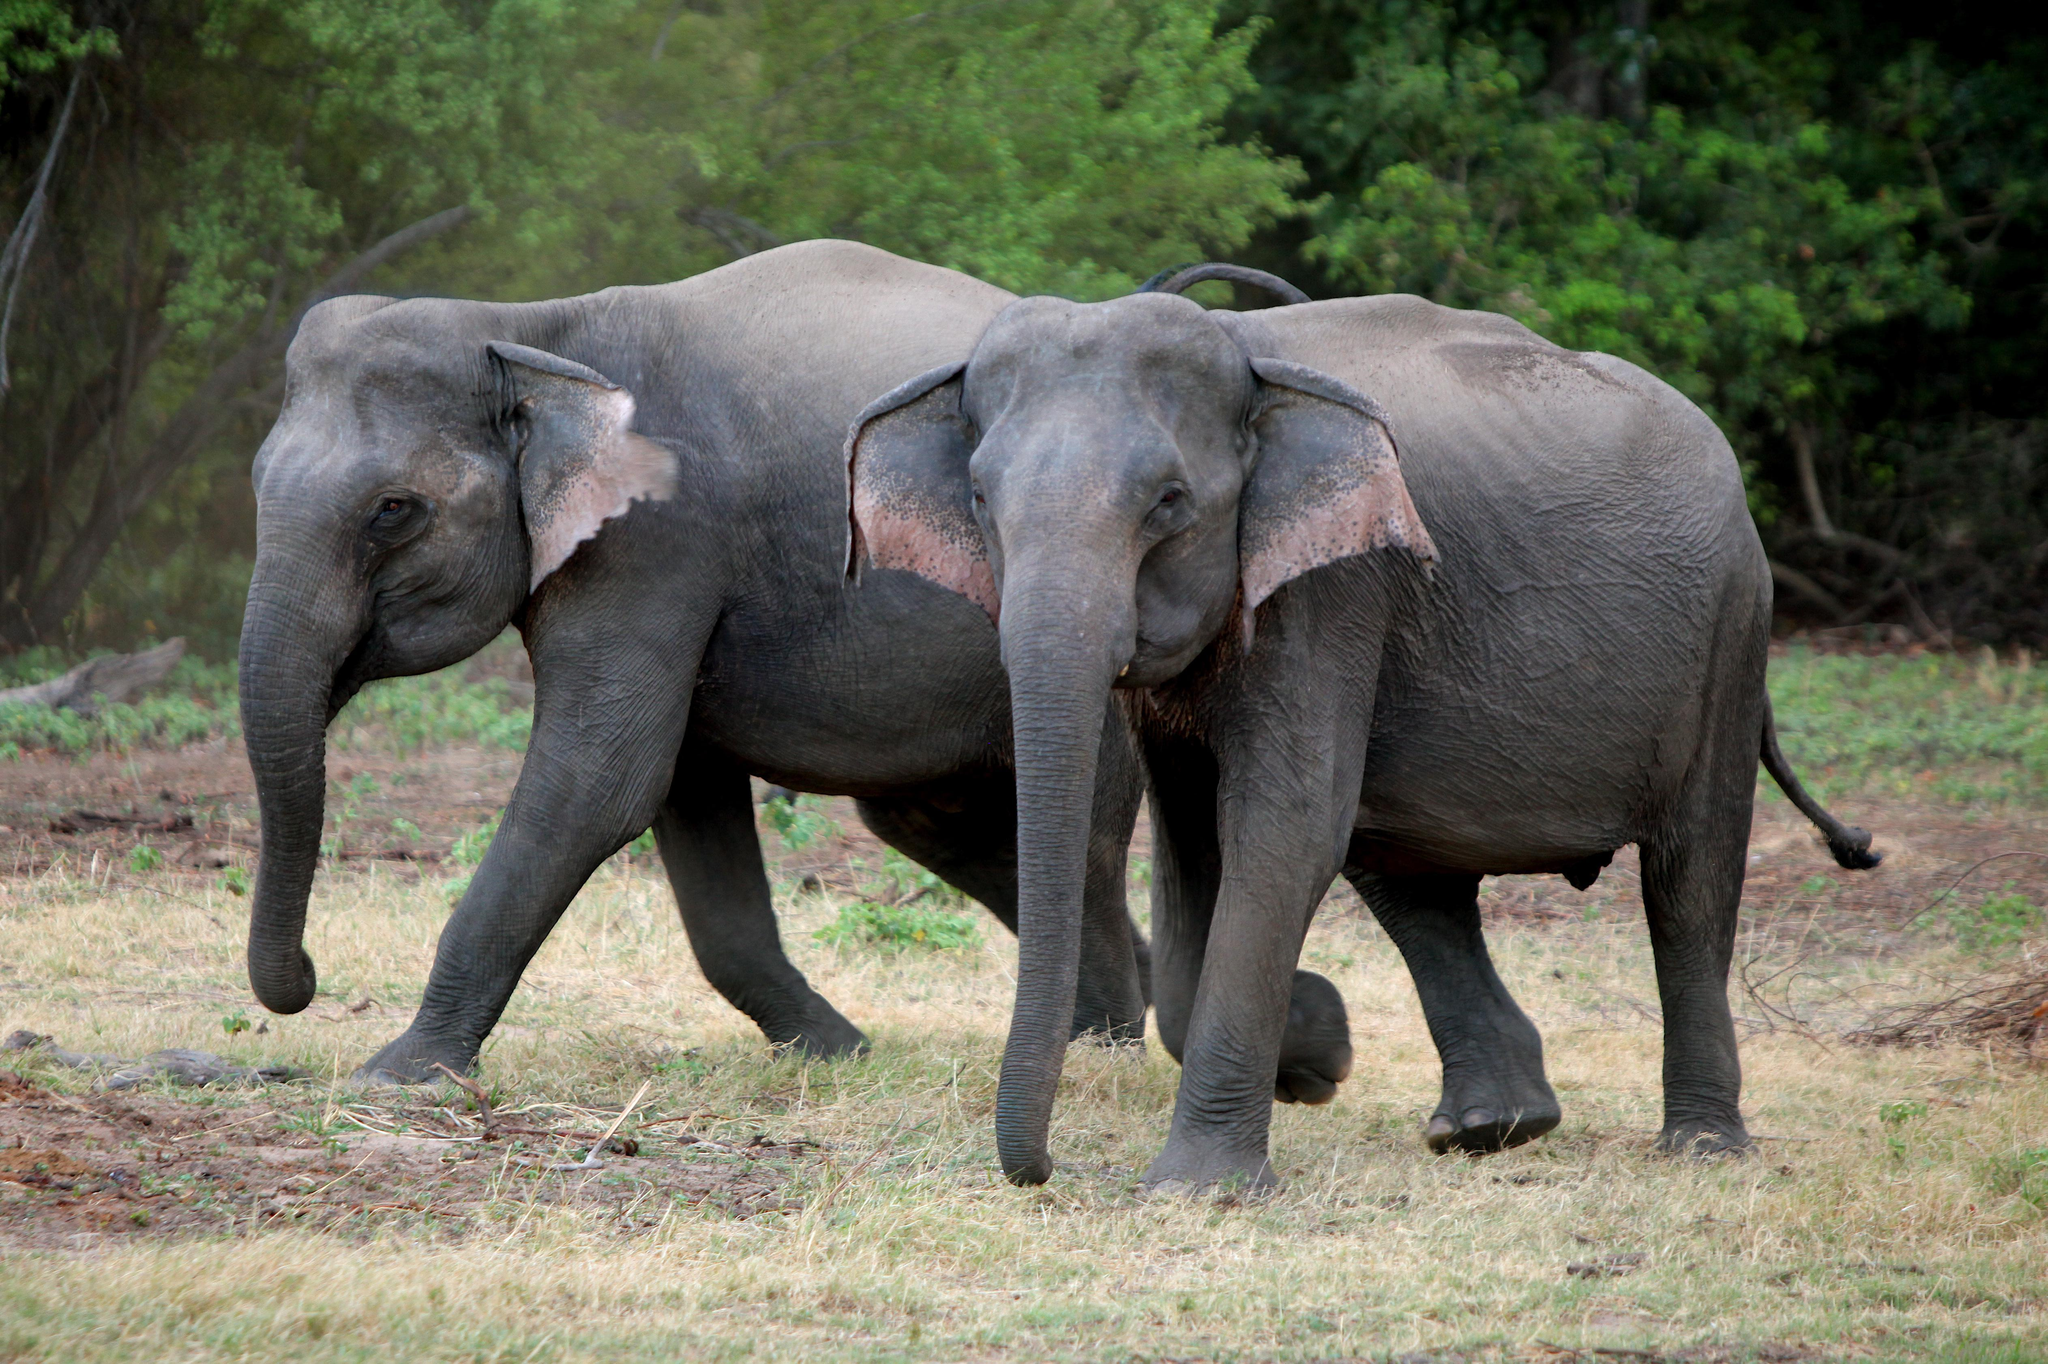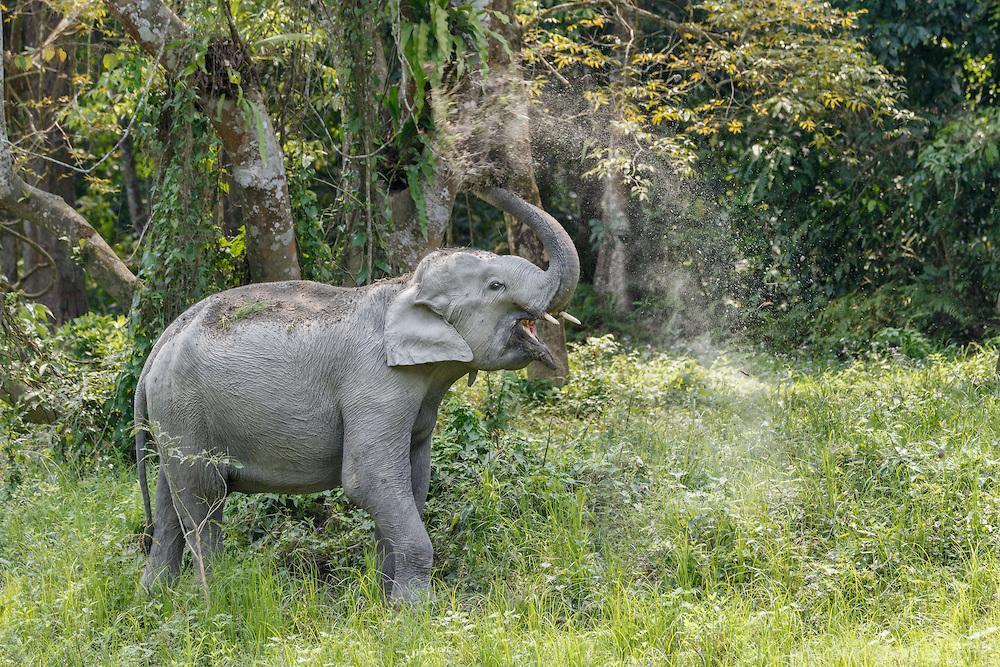The first image is the image on the left, the second image is the image on the right. Evaluate the accuracy of this statement regarding the images: "Each picture has only one elephant in it.". Is it true? Answer yes or no. No. The first image is the image on the left, the second image is the image on the right. Given the left and right images, does the statement "An elephant is in profile facing the right." hold true? Answer yes or no. Yes. 